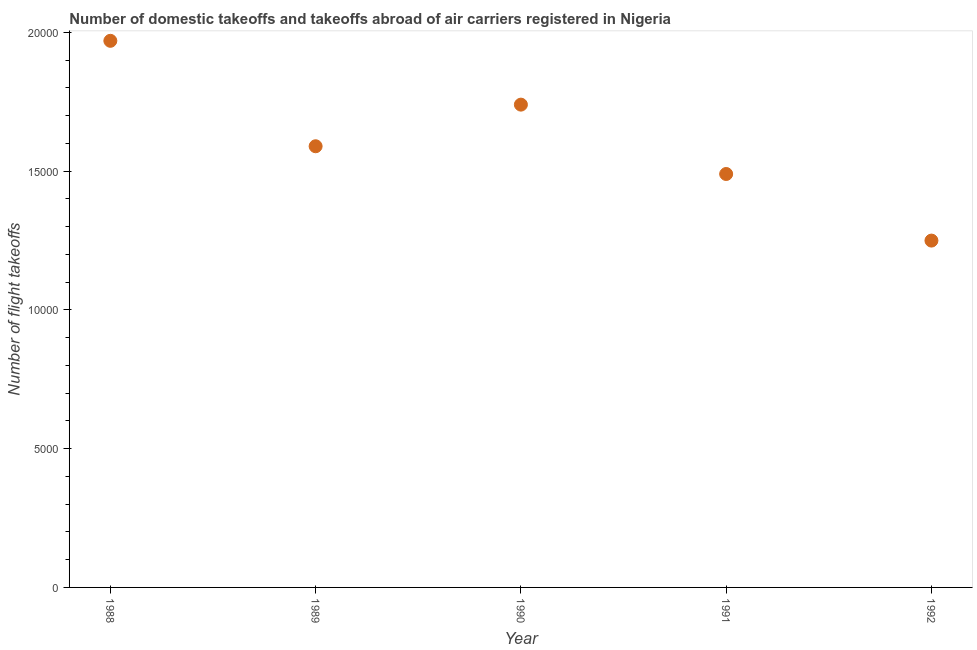What is the number of flight takeoffs in 1992?
Ensure brevity in your answer.  1.25e+04. Across all years, what is the maximum number of flight takeoffs?
Your response must be concise. 1.97e+04. Across all years, what is the minimum number of flight takeoffs?
Your answer should be compact. 1.25e+04. What is the sum of the number of flight takeoffs?
Your answer should be compact. 8.04e+04. What is the difference between the number of flight takeoffs in 1989 and 1992?
Your response must be concise. 3400. What is the average number of flight takeoffs per year?
Give a very brief answer. 1.61e+04. What is the median number of flight takeoffs?
Your response must be concise. 1.59e+04. In how many years, is the number of flight takeoffs greater than 6000 ?
Make the answer very short. 5. What is the ratio of the number of flight takeoffs in 1988 to that in 1989?
Offer a very short reply. 1.24. Is the difference between the number of flight takeoffs in 1988 and 1989 greater than the difference between any two years?
Offer a terse response. No. What is the difference between the highest and the second highest number of flight takeoffs?
Your answer should be very brief. 2300. What is the difference between the highest and the lowest number of flight takeoffs?
Provide a succinct answer. 7200. How many dotlines are there?
Your answer should be compact. 1. What is the difference between two consecutive major ticks on the Y-axis?
Offer a terse response. 5000. Does the graph contain any zero values?
Offer a terse response. No. Does the graph contain grids?
Keep it short and to the point. No. What is the title of the graph?
Your response must be concise. Number of domestic takeoffs and takeoffs abroad of air carriers registered in Nigeria. What is the label or title of the X-axis?
Ensure brevity in your answer.  Year. What is the label or title of the Y-axis?
Your answer should be very brief. Number of flight takeoffs. What is the Number of flight takeoffs in 1988?
Give a very brief answer. 1.97e+04. What is the Number of flight takeoffs in 1989?
Offer a terse response. 1.59e+04. What is the Number of flight takeoffs in 1990?
Ensure brevity in your answer.  1.74e+04. What is the Number of flight takeoffs in 1991?
Make the answer very short. 1.49e+04. What is the Number of flight takeoffs in 1992?
Provide a succinct answer. 1.25e+04. What is the difference between the Number of flight takeoffs in 1988 and 1989?
Offer a terse response. 3800. What is the difference between the Number of flight takeoffs in 1988 and 1990?
Offer a terse response. 2300. What is the difference between the Number of flight takeoffs in 1988 and 1991?
Give a very brief answer. 4800. What is the difference between the Number of flight takeoffs in 1988 and 1992?
Make the answer very short. 7200. What is the difference between the Number of flight takeoffs in 1989 and 1990?
Offer a very short reply. -1500. What is the difference between the Number of flight takeoffs in 1989 and 1991?
Provide a succinct answer. 1000. What is the difference between the Number of flight takeoffs in 1989 and 1992?
Your answer should be compact. 3400. What is the difference between the Number of flight takeoffs in 1990 and 1991?
Provide a succinct answer. 2500. What is the difference between the Number of flight takeoffs in 1990 and 1992?
Your answer should be compact. 4900. What is the difference between the Number of flight takeoffs in 1991 and 1992?
Provide a short and direct response. 2400. What is the ratio of the Number of flight takeoffs in 1988 to that in 1989?
Your answer should be compact. 1.24. What is the ratio of the Number of flight takeoffs in 1988 to that in 1990?
Provide a succinct answer. 1.13. What is the ratio of the Number of flight takeoffs in 1988 to that in 1991?
Give a very brief answer. 1.32. What is the ratio of the Number of flight takeoffs in 1988 to that in 1992?
Make the answer very short. 1.58. What is the ratio of the Number of flight takeoffs in 1989 to that in 1990?
Make the answer very short. 0.91. What is the ratio of the Number of flight takeoffs in 1989 to that in 1991?
Provide a succinct answer. 1.07. What is the ratio of the Number of flight takeoffs in 1989 to that in 1992?
Keep it short and to the point. 1.27. What is the ratio of the Number of flight takeoffs in 1990 to that in 1991?
Offer a very short reply. 1.17. What is the ratio of the Number of flight takeoffs in 1990 to that in 1992?
Provide a short and direct response. 1.39. What is the ratio of the Number of flight takeoffs in 1991 to that in 1992?
Your answer should be compact. 1.19. 